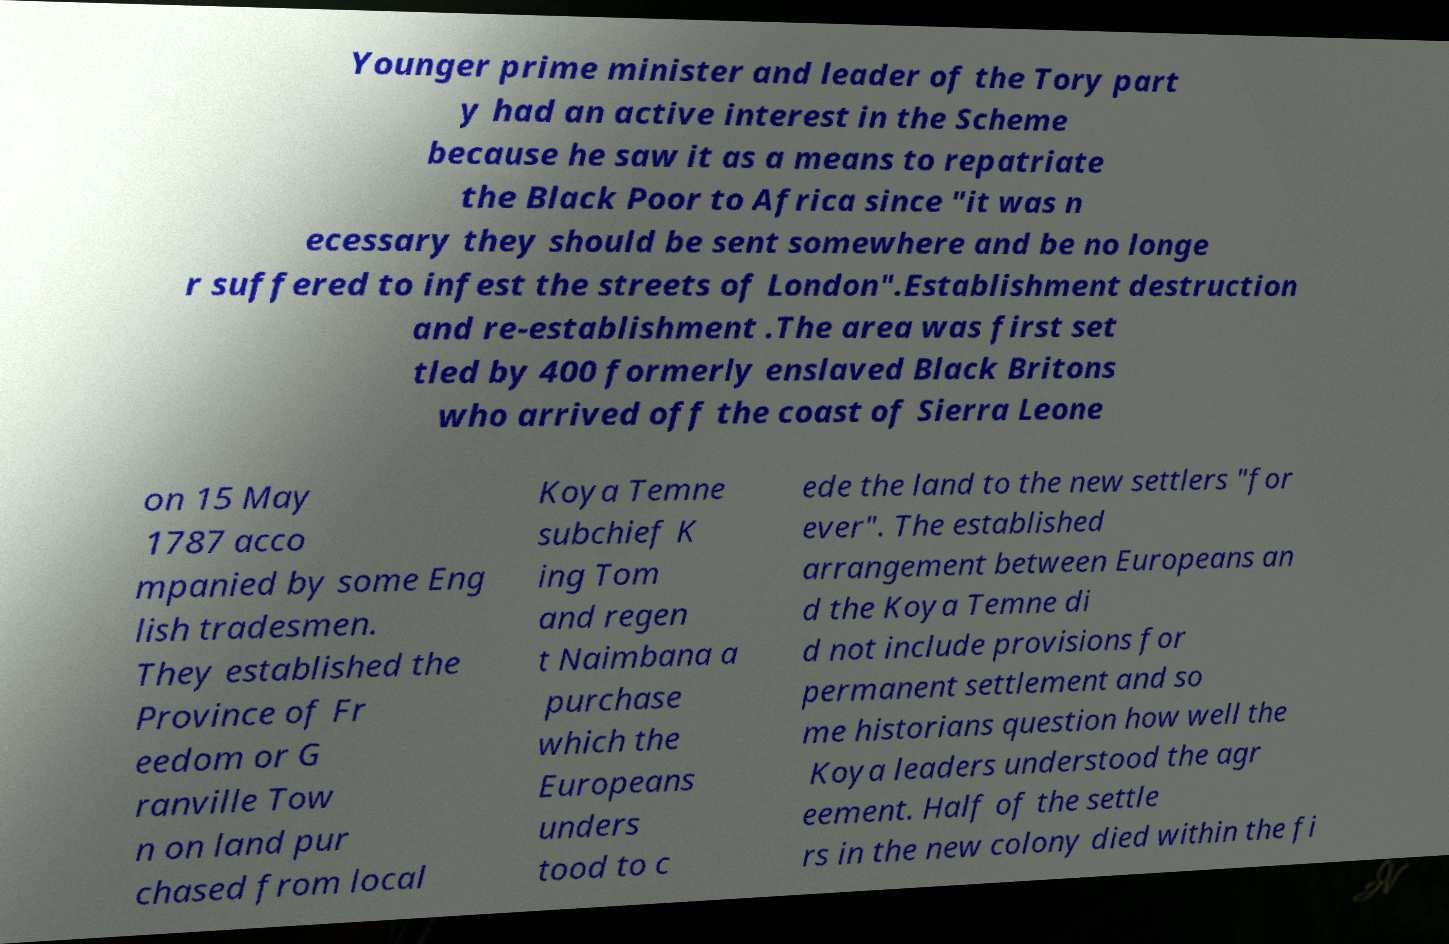Can you read and provide the text displayed in the image?This photo seems to have some interesting text. Can you extract and type it out for me? Younger prime minister and leader of the Tory part y had an active interest in the Scheme because he saw it as a means to repatriate the Black Poor to Africa since "it was n ecessary they should be sent somewhere and be no longe r suffered to infest the streets of London".Establishment destruction and re-establishment .The area was first set tled by 400 formerly enslaved Black Britons who arrived off the coast of Sierra Leone on 15 May 1787 acco mpanied by some Eng lish tradesmen. They established the Province of Fr eedom or G ranville Tow n on land pur chased from local Koya Temne subchief K ing Tom and regen t Naimbana a purchase which the Europeans unders tood to c ede the land to the new settlers "for ever". The established arrangement between Europeans an d the Koya Temne di d not include provisions for permanent settlement and so me historians question how well the Koya leaders understood the agr eement. Half of the settle rs in the new colony died within the fi 